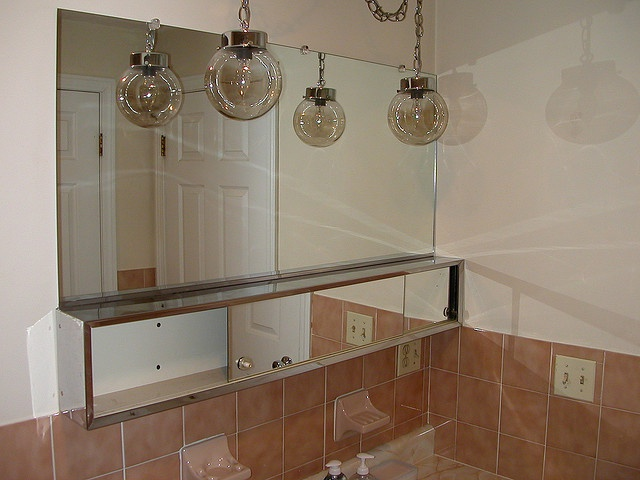Describe the objects in this image and their specific colors. I can see sink in gray, brown, and darkgray tones and bottle in darkgray and gray tones in this image. 